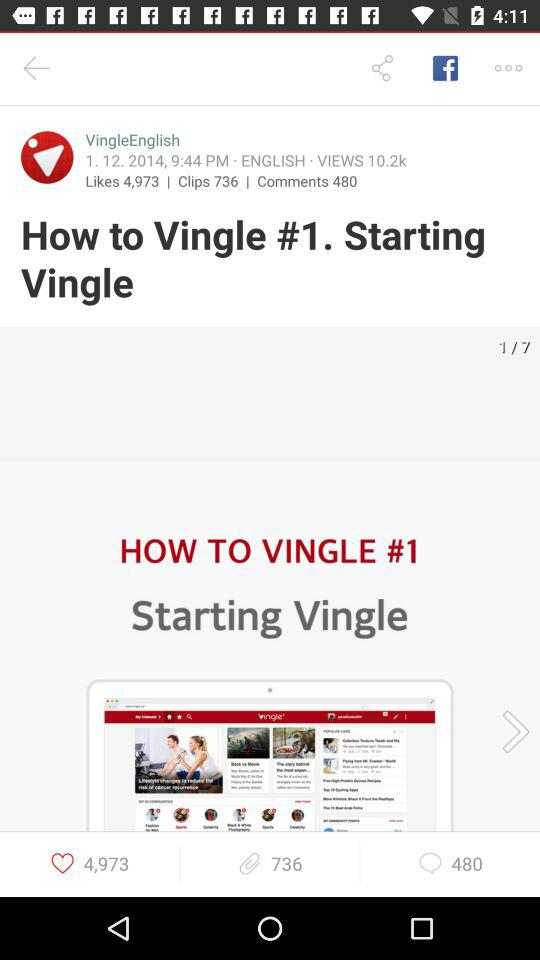What is the number of clips? The number of clips is 736. 